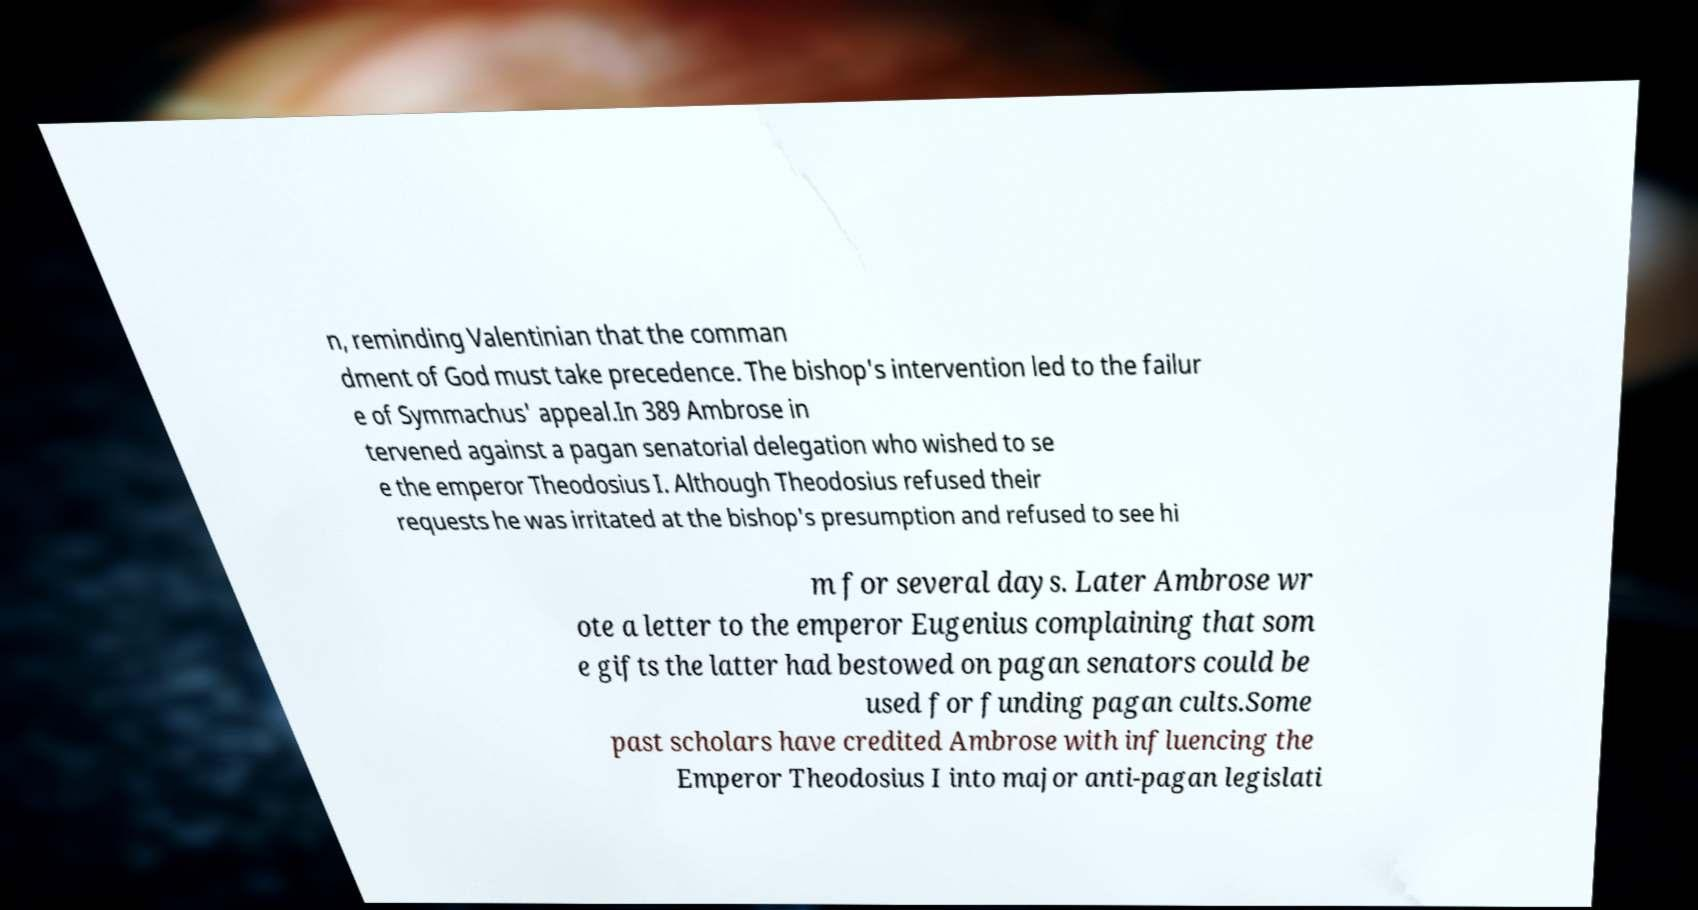I need the written content from this picture converted into text. Can you do that? n, reminding Valentinian that the comman dment of God must take precedence. The bishop's intervention led to the failur e of Symmachus' appeal.In 389 Ambrose in tervened against a pagan senatorial delegation who wished to se e the emperor Theodosius I. Although Theodosius refused their requests he was irritated at the bishop's presumption and refused to see hi m for several days. Later Ambrose wr ote a letter to the emperor Eugenius complaining that som e gifts the latter had bestowed on pagan senators could be used for funding pagan cults.Some past scholars have credited Ambrose with influencing the Emperor Theodosius I into major anti-pagan legislati 